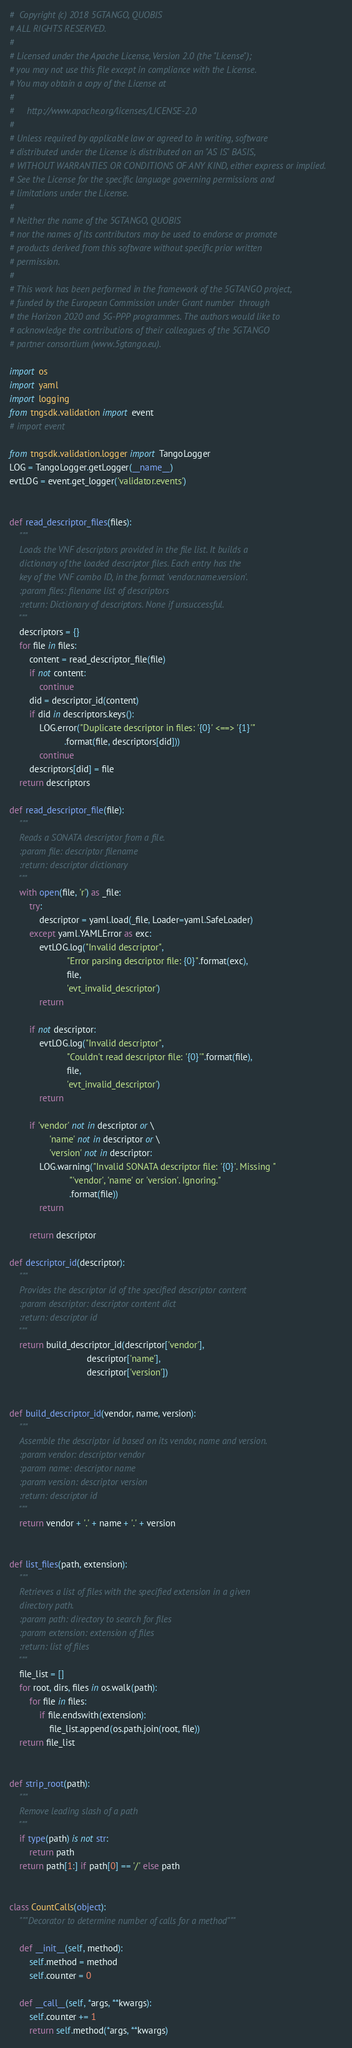<code> <loc_0><loc_0><loc_500><loc_500><_Python_>#  Copyright (c) 2018 5GTANGO, QUOBIS
# ALL RIGHTS RESERVED.
#
# Licensed under the Apache License, Version 2.0 (the "License");
# you may not use this file except in compliance with the License.
# You may obtain a copy of the License at
#
#     http://www.apache.org/licenses/LICENSE-2.0
#
# Unless required by applicable law or agreed to in writing, software
# distributed under the License is distributed on an "AS IS" BASIS,
# WITHOUT WARRANTIES OR CONDITIONS OF ANY KIND, either express or implied.
# See the License for the specific language governing permissions and
# limitations under the License.
#
# Neither the name of the 5GTANGO, QUOBIS
# nor the names of its contributors may be used to endorse or promote
# products derived from this software without specific prior written
# permission.
#
# This work has been performed in the framework of the 5GTANGO project,
# funded by the European Commission under Grant number  through
# the Horizon 2020 and 5G-PPP programmes. The authors would like to
# acknowledge the contributions of their colleagues of the 5GTANGO
# partner consortium (www.5gtango.eu).

import os
import yaml
import logging
from tngsdk.validation import event
# import event

from tngsdk.validation.logger import TangoLogger
LOG = TangoLogger.getLogger(__name__)
evtLOG = event.get_logger('validator.events')


def read_descriptor_files(files):
    """
    Loads the VNF descriptors provided in the file list. It builds a
    dictionary of the loaded descriptor files. Each entry has the
    key of the VNF combo ID, in the format 'vendor.name.version'.
    :param files: filename list of descriptors
    :return: Dictionary of descriptors. None if unsuccessful.
    """
    descriptors = {}
    for file in files:
        content = read_descriptor_file(file)
        if not content:
            continue
        did = descriptor_id(content)
        if did in descriptors.keys():
            LOG.error("Duplicate descriptor in files: '{0}' <==> '{1}'"
                      .format(file, descriptors[did]))
            continue
        descriptors[did] = file
    return descriptors

def read_descriptor_file(file):
    """
    Reads a SONATA descriptor from a file.
    :param file: descriptor filename
    :return: descriptor dictionary
    """
    with open(file, 'r') as _file:
        try:
            descriptor = yaml.load(_file, Loader=yaml.SafeLoader)
        except yaml.YAMLError as exc:
            evtLOG.log("Invalid descriptor",
                       "Error parsing descriptor file: {0}".format(exc),
                       file,
                       'evt_invalid_descriptor')
            return

        if not descriptor:
            evtLOG.log("Invalid descriptor",
                       "Couldn't read descriptor file: '{0}'".format(file),
                       file,
                       'evt_invalid_descriptor')
            return

        if 'vendor' not in descriptor or \
                'name' not in descriptor or \
                'version' not in descriptor:
            LOG.warning("Invalid SONATA descriptor file: '{0}'. Missing "
                        "'vendor', 'name' or 'version'. Ignoring."
                        .format(file))
            return

        return descriptor

def descriptor_id(descriptor):
    """
    Provides the descriptor id of the specified descriptor content
    :param descriptor: descriptor content dict
    :return: descriptor id
    """
    return build_descriptor_id(descriptor['vendor'],
                               descriptor['name'],
                               descriptor['version'])


def build_descriptor_id(vendor, name, version):
    """
    Assemble the descriptor id based on its vendor, name and version.
    :param vendor: descriptor vendor
    :param name: descriptor name
    :param version: descriptor version
    :return: descriptor id
    """
    return vendor + '.' + name + '.' + version


def list_files(path, extension):
    """
    Retrieves a list of files with the specified extension in a given
    directory path.
    :param path: directory to search for files
    :param extension: extension of files
    :return: list of files
    """
    file_list = []
    for root, dirs, files in os.walk(path):
        for file in files:
            if file.endswith(extension):
                file_list.append(os.path.join(root, file))
    return file_list


def strip_root(path):
    """
    Remove leading slash of a path
    """
    if type(path) is not str:
        return path
    return path[1:] if path[0] == '/' else path


class CountCalls(object):
    """Decorator to determine number of calls for a method"""

    def __init__(self, method):
        self.method = method
        self.counter = 0

    def __call__(self, *args, **kwargs):
        self.counter += 1
        return self.method(*args, **kwargs)
</code> 